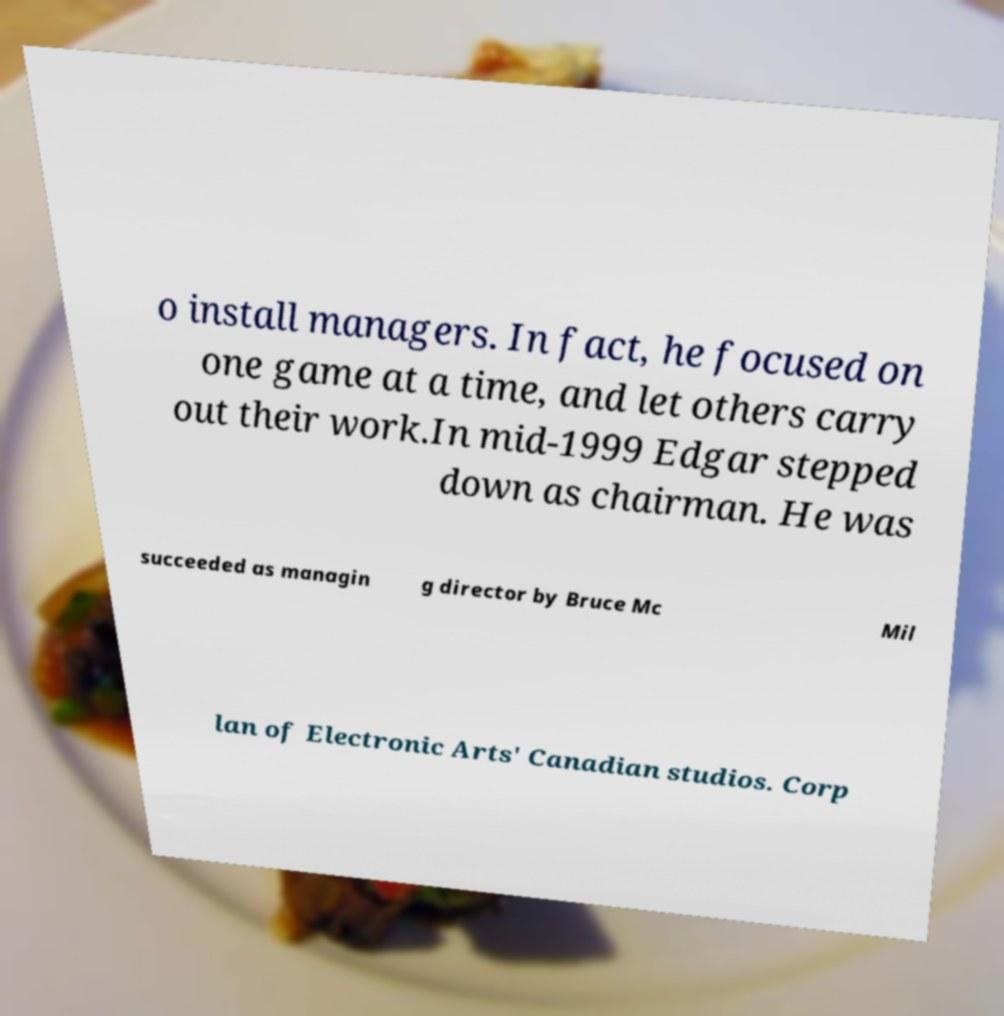For documentation purposes, I need the text within this image transcribed. Could you provide that? o install managers. In fact, he focused on one game at a time, and let others carry out their work.In mid-1999 Edgar stepped down as chairman. He was succeeded as managin g director by Bruce Mc Mil lan of Electronic Arts' Canadian studios. Corp 